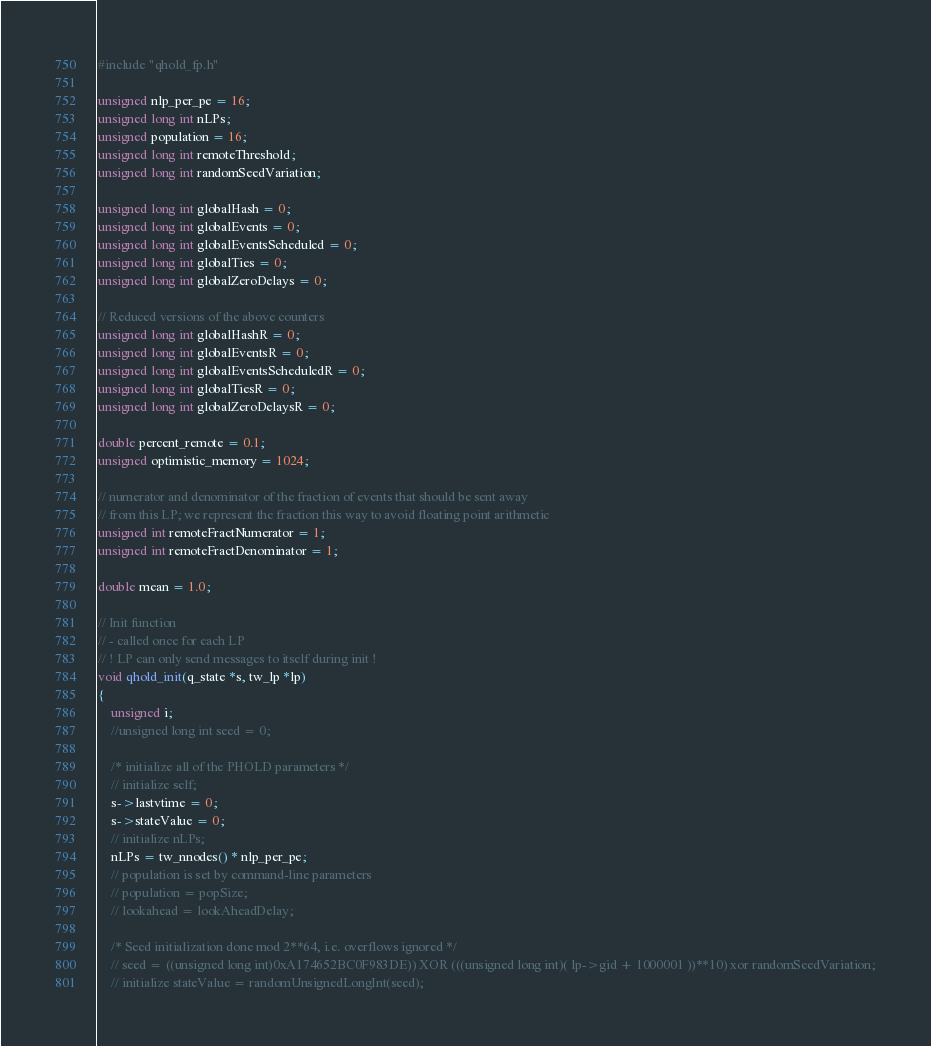Convert code to text. <code><loc_0><loc_0><loc_500><loc_500><_C_>#include "qhold_fp.h"

unsigned nlp_per_pe = 16;
unsigned long int nLPs;
unsigned population = 16;
unsigned long int remoteThreshold;
unsigned long int randomSeedVariation;

unsigned long int globalHash = 0;
unsigned long int globalEvents = 0;
unsigned long int globalEventsScheduled = 0;
unsigned long int globalTies = 0;
unsigned long int globalZeroDelays = 0;

// Reduced versions of the above counters
unsigned long int globalHashR = 0;
unsigned long int globalEventsR = 0;
unsigned long int globalEventsScheduledR = 0;
unsigned long int globalTiesR = 0;
unsigned long int globalZeroDelaysR = 0;

double percent_remote = 0.1;
unsigned optimistic_memory = 1024;

// numerator and denominator of the fraction of events that should be sent away
// from this LP; we represent the fraction this way to avoid floating point arithmetic
unsigned int remoteFractNumerator = 1;
unsigned int remoteFractDenominator = 1;

double mean = 1.0;

// Init function
// - called once for each LP
// ! LP can only send messages to itself during init !
void qhold_init(q_state *s, tw_lp *lp)
{
    unsigned i;
    //unsigned long int seed = 0;
    
    /* initialize all of the PHOLD parameters */
	// initialize self;
    s->lastvtime = 0;
    s->stateValue = 0;
	// initialize nLPs;
    nLPs = tw_nnodes() * nlp_per_pe;
    // population is set by command-line parameters
	// population = popSize;
	// lookahead = lookAheadDelay;
    
	/* Seed initialization done mod 2**64, i.e. overflows ignored */
	// seed = ((unsigned long int)0xA174652BC0F983DE)) XOR (((unsigned long int)( lp->gid + 1000001 ))**10) xor randomSeedVariation;
    // initialize stateValue = randomUnsignedLongInt(seed);</code> 